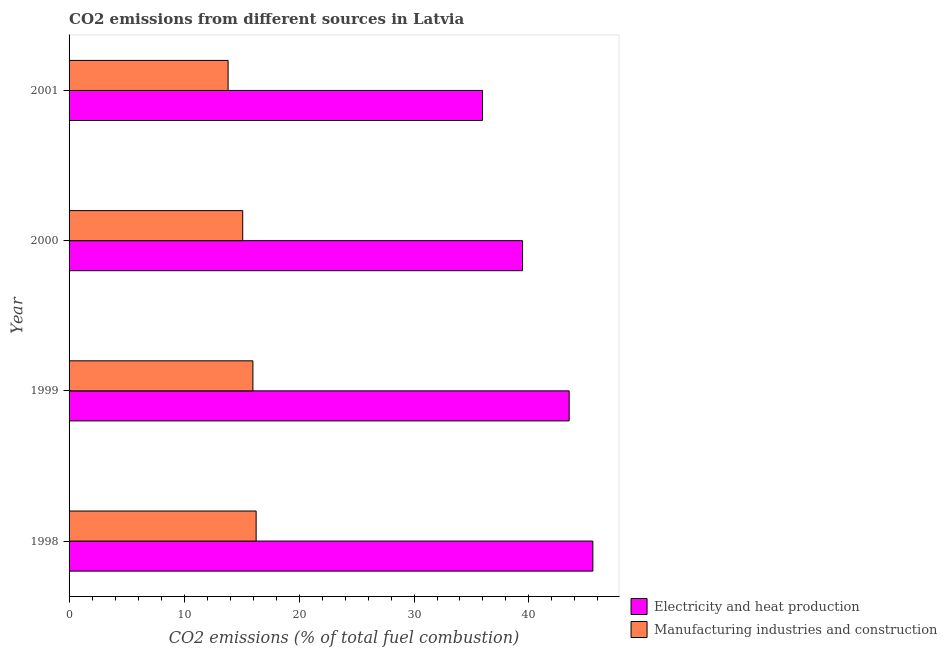Are the number of bars per tick equal to the number of legend labels?
Keep it short and to the point. Yes. Are the number of bars on each tick of the Y-axis equal?
Your answer should be very brief. Yes. How many bars are there on the 2nd tick from the top?
Your answer should be compact. 2. How many bars are there on the 2nd tick from the bottom?
Keep it short and to the point. 2. What is the co2 emissions due to electricity and heat production in 1998?
Provide a short and direct response. 45.56. Across all years, what is the maximum co2 emissions due to electricity and heat production?
Make the answer very short. 45.56. Across all years, what is the minimum co2 emissions due to manufacturing industries?
Keep it short and to the point. 13.83. In which year was the co2 emissions due to manufacturing industries minimum?
Your answer should be very brief. 2001. What is the total co2 emissions due to manufacturing industries in the graph?
Keep it short and to the point. 61.19. What is the difference between the co2 emissions due to manufacturing industries in 1998 and that in 2000?
Your response must be concise. 1.17. What is the difference between the co2 emissions due to manufacturing industries in 1998 and the co2 emissions due to electricity and heat production in 2000?
Provide a succinct answer. -23.17. What is the average co2 emissions due to manufacturing industries per year?
Offer a terse response. 15.3. In the year 2000, what is the difference between the co2 emissions due to manufacturing industries and co2 emissions due to electricity and heat production?
Your response must be concise. -24.34. In how many years, is the co2 emissions due to manufacturing industries greater than 42 %?
Your answer should be compact. 0. What is the ratio of the co2 emissions due to electricity and heat production in 1999 to that in 2000?
Your answer should be compact. 1.1. Is the co2 emissions due to manufacturing industries in 2000 less than that in 2001?
Provide a succinct answer. No. Is the difference between the co2 emissions due to electricity and heat production in 1998 and 2001 greater than the difference between the co2 emissions due to manufacturing industries in 1998 and 2001?
Your answer should be compact. Yes. What is the difference between the highest and the second highest co2 emissions due to electricity and heat production?
Make the answer very short. 2.06. What is the difference between the highest and the lowest co2 emissions due to electricity and heat production?
Keep it short and to the point. 9.6. In how many years, is the co2 emissions due to electricity and heat production greater than the average co2 emissions due to electricity and heat production taken over all years?
Ensure brevity in your answer.  2. What does the 2nd bar from the top in 1998 represents?
Your response must be concise. Electricity and heat production. What does the 2nd bar from the bottom in 2001 represents?
Provide a short and direct response. Manufacturing industries and construction. Are all the bars in the graph horizontal?
Ensure brevity in your answer.  Yes. Does the graph contain any zero values?
Give a very brief answer. No. Does the graph contain grids?
Offer a very short reply. No. Where does the legend appear in the graph?
Offer a very short reply. Bottom right. How are the legend labels stacked?
Provide a short and direct response. Vertical. What is the title of the graph?
Provide a succinct answer. CO2 emissions from different sources in Latvia. Does "Secondary education" appear as one of the legend labels in the graph?
Make the answer very short. No. What is the label or title of the X-axis?
Your response must be concise. CO2 emissions (% of total fuel combustion). What is the label or title of the Y-axis?
Keep it short and to the point. Year. What is the CO2 emissions (% of total fuel combustion) of Electricity and heat production in 1998?
Offer a terse response. 45.56. What is the CO2 emissions (% of total fuel combustion) in Manufacturing industries and construction in 1998?
Ensure brevity in your answer.  16.27. What is the CO2 emissions (% of total fuel combustion) in Electricity and heat production in 1999?
Offer a very short reply. 43.5. What is the CO2 emissions (% of total fuel combustion) of Manufacturing industries and construction in 1999?
Provide a short and direct response. 15.99. What is the CO2 emissions (% of total fuel combustion) in Electricity and heat production in 2000?
Keep it short and to the point. 39.44. What is the CO2 emissions (% of total fuel combustion) of Manufacturing industries and construction in 2000?
Your answer should be compact. 15.1. What is the CO2 emissions (% of total fuel combustion) of Electricity and heat production in 2001?
Make the answer very short. 35.96. What is the CO2 emissions (% of total fuel combustion) in Manufacturing industries and construction in 2001?
Keep it short and to the point. 13.83. Across all years, what is the maximum CO2 emissions (% of total fuel combustion) of Electricity and heat production?
Give a very brief answer. 45.56. Across all years, what is the maximum CO2 emissions (% of total fuel combustion) of Manufacturing industries and construction?
Your answer should be very brief. 16.27. Across all years, what is the minimum CO2 emissions (% of total fuel combustion) of Electricity and heat production?
Keep it short and to the point. 35.96. Across all years, what is the minimum CO2 emissions (% of total fuel combustion) in Manufacturing industries and construction?
Your answer should be compact. 13.83. What is the total CO2 emissions (% of total fuel combustion) of Electricity and heat production in the graph?
Your answer should be very brief. 164.46. What is the total CO2 emissions (% of total fuel combustion) of Manufacturing industries and construction in the graph?
Keep it short and to the point. 61.19. What is the difference between the CO2 emissions (% of total fuel combustion) in Electricity and heat production in 1998 and that in 1999?
Keep it short and to the point. 2.06. What is the difference between the CO2 emissions (% of total fuel combustion) of Manufacturing industries and construction in 1998 and that in 1999?
Provide a succinct answer. 0.28. What is the difference between the CO2 emissions (% of total fuel combustion) in Electricity and heat production in 1998 and that in 2000?
Your response must be concise. 6.11. What is the difference between the CO2 emissions (% of total fuel combustion) in Manufacturing industries and construction in 1998 and that in 2000?
Your answer should be compact. 1.17. What is the difference between the CO2 emissions (% of total fuel combustion) of Electricity and heat production in 1998 and that in 2001?
Give a very brief answer. 9.6. What is the difference between the CO2 emissions (% of total fuel combustion) of Manufacturing industries and construction in 1998 and that in 2001?
Keep it short and to the point. 2.44. What is the difference between the CO2 emissions (% of total fuel combustion) of Electricity and heat production in 1999 and that in 2000?
Ensure brevity in your answer.  4.05. What is the difference between the CO2 emissions (% of total fuel combustion) of Manufacturing industries and construction in 1999 and that in 2000?
Keep it short and to the point. 0.89. What is the difference between the CO2 emissions (% of total fuel combustion) of Electricity and heat production in 1999 and that in 2001?
Keep it short and to the point. 7.53. What is the difference between the CO2 emissions (% of total fuel combustion) in Manufacturing industries and construction in 1999 and that in 2001?
Your answer should be compact. 2.16. What is the difference between the CO2 emissions (% of total fuel combustion) in Electricity and heat production in 2000 and that in 2001?
Your response must be concise. 3.48. What is the difference between the CO2 emissions (% of total fuel combustion) of Manufacturing industries and construction in 2000 and that in 2001?
Keep it short and to the point. 1.27. What is the difference between the CO2 emissions (% of total fuel combustion) in Electricity and heat production in 1998 and the CO2 emissions (% of total fuel combustion) in Manufacturing industries and construction in 1999?
Offer a terse response. 29.57. What is the difference between the CO2 emissions (% of total fuel combustion) in Electricity and heat production in 1998 and the CO2 emissions (% of total fuel combustion) in Manufacturing industries and construction in 2000?
Offer a very short reply. 30.45. What is the difference between the CO2 emissions (% of total fuel combustion) in Electricity and heat production in 1998 and the CO2 emissions (% of total fuel combustion) in Manufacturing industries and construction in 2001?
Give a very brief answer. 31.73. What is the difference between the CO2 emissions (% of total fuel combustion) in Electricity and heat production in 1999 and the CO2 emissions (% of total fuel combustion) in Manufacturing industries and construction in 2000?
Give a very brief answer. 28.39. What is the difference between the CO2 emissions (% of total fuel combustion) of Electricity and heat production in 1999 and the CO2 emissions (% of total fuel combustion) of Manufacturing industries and construction in 2001?
Provide a succinct answer. 29.66. What is the difference between the CO2 emissions (% of total fuel combustion) in Electricity and heat production in 2000 and the CO2 emissions (% of total fuel combustion) in Manufacturing industries and construction in 2001?
Your answer should be compact. 25.61. What is the average CO2 emissions (% of total fuel combustion) in Electricity and heat production per year?
Offer a terse response. 41.11. What is the average CO2 emissions (% of total fuel combustion) of Manufacturing industries and construction per year?
Offer a terse response. 15.3. In the year 1998, what is the difference between the CO2 emissions (% of total fuel combustion) in Electricity and heat production and CO2 emissions (% of total fuel combustion) in Manufacturing industries and construction?
Offer a very short reply. 29.29. In the year 1999, what is the difference between the CO2 emissions (% of total fuel combustion) in Electricity and heat production and CO2 emissions (% of total fuel combustion) in Manufacturing industries and construction?
Offer a terse response. 27.51. In the year 2000, what is the difference between the CO2 emissions (% of total fuel combustion) in Electricity and heat production and CO2 emissions (% of total fuel combustion) in Manufacturing industries and construction?
Offer a very short reply. 24.34. In the year 2001, what is the difference between the CO2 emissions (% of total fuel combustion) in Electricity and heat production and CO2 emissions (% of total fuel combustion) in Manufacturing industries and construction?
Keep it short and to the point. 22.13. What is the ratio of the CO2 emissions (% of total fuel combustion) of Electricity and heat production in 1998 to that in 1999?
Your response must be concise. 1.05. What is the ratio of the CO2 emissions (% of total fuel combustion) in Manufacturing industries and construction in 1998 to that in 1999?
Make the answer very short. 1.02. What is the ratio of the CO2 emissions (% of total fuel combustion) in Electricity and heat production in 1998 to that in 2000?
Your answer should be compact. 1.16. What is the ratio of the CO2 emissions (% of total fuel combustion) of Manufacturing industries and construction in 1998 to that in 2000?
Keep it short and to the point. 1.08. What is the ratio of the CO2 emissions (% of total fuel combustion) in Electricity and heat production in 1998 to that in 2001?
Your answer should be compact. 1.27. What is the ratio of the CO2 emissions (% of total fuel combustion) of Manufacturing industries and construction in 1998 to that in 2001?
Give a very brief answer. 1.18. What is the ratio of the CO2 emissions (% of total fuel combustion) of Electricity and heat production in 1999 to that in 2000?
Keep it short and to the point. 1.1. What is the ratio of the CO2 emissions (% of total fuel combustion) of Manufacturing industries and construction in 1999 to that in 2000?
Your answer should be very brief. 1.06. What is the ratio of the CO2 emissions (% of total fuel combustion) in Electricity and heat production in 1999 to that in 2001?
Provide a succinct answer. 1.21. What is the ratio of the CO2 emissions (% of total fuel combustion) in Manufacturing industries and construction in 1999 to that in 2001?
Your answer should be compact. 1.16. What is the ratio of the CO2 emissions (% of total fuel combustion) of Electricity and heat production in 2000 to that in 2001?
Make the answer very short. 1.1. What is the ratio of the CO2 emissions (% of total fuel combustion) in Manufacturing industries and construction in 2000 to that in 2001?
Give a very brief answer. 1.09. What is the difference between the highest and the second highest CO2 emissions (% of total fuel combustion) in Electricity and heat production?
Keep it short and to the point. 2.06. What is the difference between the highest and the second highest CO2 emissions (% of total fuel combustion) in Manufacturing industries and construction?
Provide a succinct answer. 0.28. What is the difference between the highest and the lowest CO2 emissions (% of total fuel combustion) in Electricity and heat production?
Your answer should be very brief. 9.6. What is the difference between the highest and the lowest CO2 emissions (% of total fuel combustion) in Manufacturing industries and construction?
Your response must be concise. 2.44. 